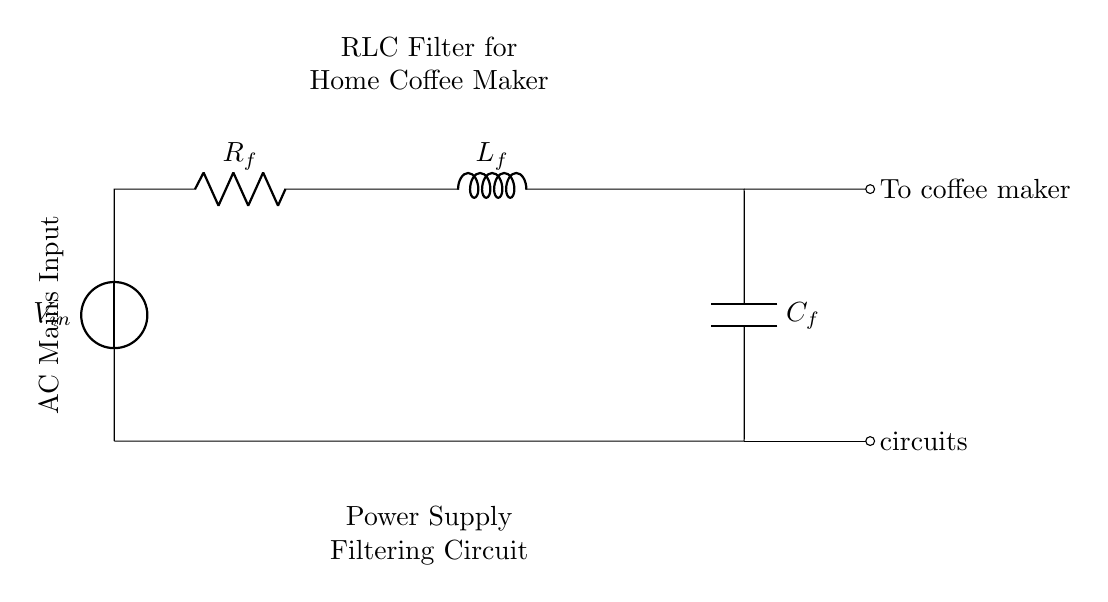What type of components are included in the circuit? The circuit includes a resistor, an inductor, and a capacitor as its primary components. These are denoted by R, L, and C respectively.
Answer: Resistor, Inductor, Capacitor What is the purpose of this RLC circuit? This RLC circuit is used for filtering the power supply to the coffee maker, smoothing the power received to ensure stable operation.
Answer: Power supply filtering What is connected to the output of the circuit? The output of the circuit is connected to the coffee maker. This indicates that it supplies filtered power directly to it.
Answer: Coffee maker How many components in the circuit are passive? All components in this circuit, which include a resistor, an inductor, and a capacitor, are passive components that do not require an external power source to operate.
Answer: Three What does the component labeled \( R_f \) indicate? \( R_f \) denotes a specific resistance value that helps to limit the current in the circuit, functioning as a filter.
Answer: Resistor for filtering Explain the role of the inductor in this circuit. The inductor smooths out the fluctuations in current and aids in allowing steady power flow while filtering out high-frequency noise from the power supply.
Answer: Smoothing current What does the capacitor do in this circuit? The capacitor stores and releases electrical energy, helping to buffer the power supply fluctuations and providing a stable output voltage for the coffee maker.
Answer: Stabilizes voltage 